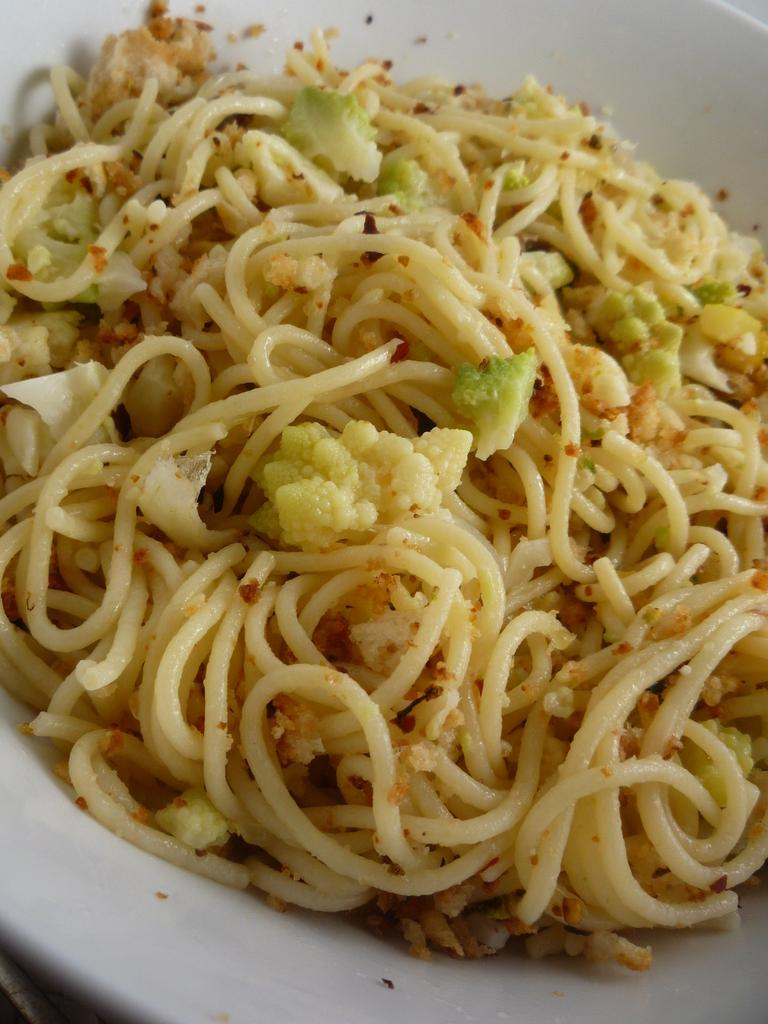What is on the plate that is visible in the image? The plate contains noodles and cauliflower pieces. What type of dish is represented by the plate's contents? The plate contains noodles, which is a type of pasta dish. What type of bottle is visible in the image? There is no bottle present in the image. Is there a fireman in the image? There is no fireman present in the image. 